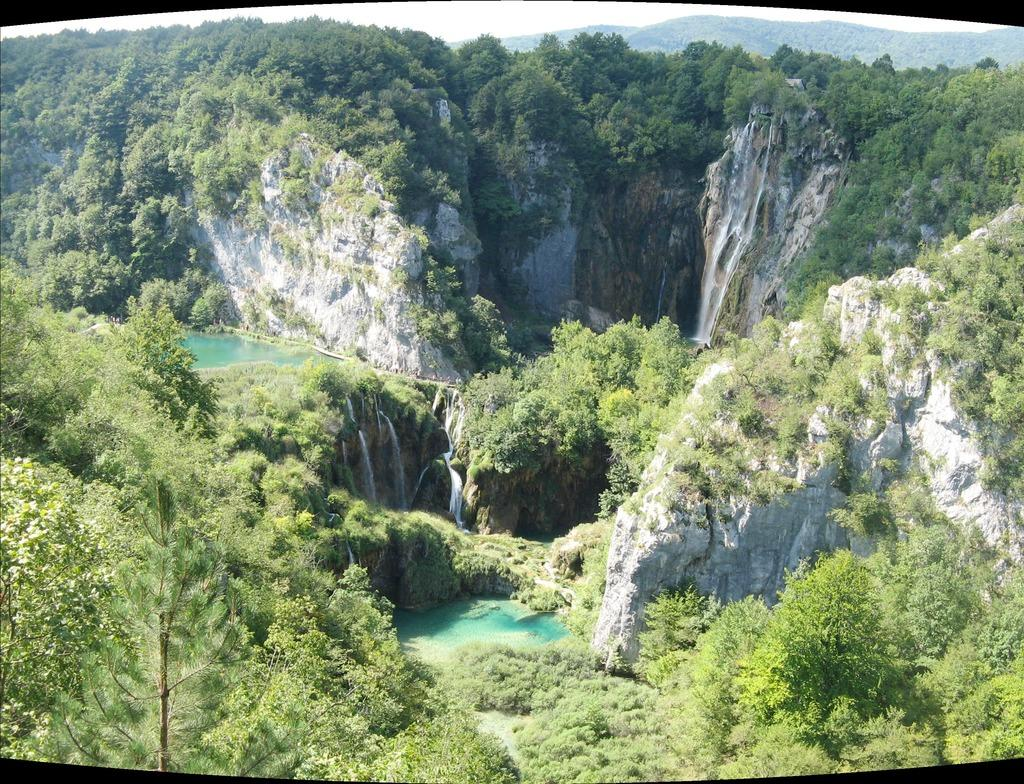What is the main feature in the center of the image? There are mountains in the center of the image. What type of vegetation can be seen in the image? There are trees in the image. What natural element is visible in the image? There is water visible in the image. How many hands are visible in the image? There are no hands visible in the image; it features mountains, trees, and water. Can you see anyone jumping in the image? There is no one present in the image to perform a jump. 